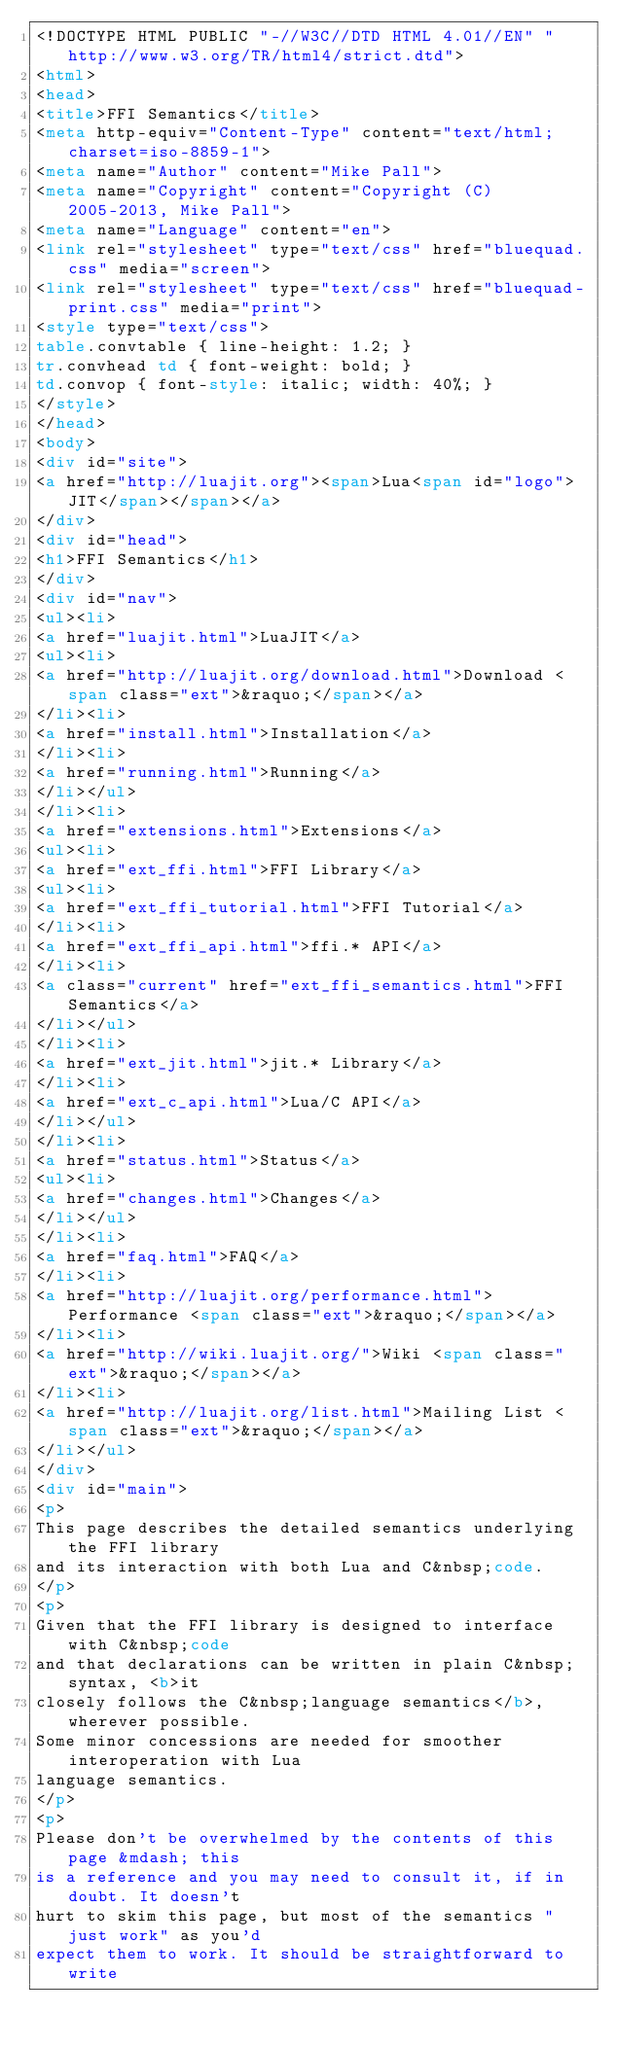Convert code to text. <code><loc_0><loc_0><loc_500><loc_500><_HTML_><!DOCTYPE HTML PUBLIC "-//W3C//DTD HTML 4.01//EN" "http://www.w3.org/TR/html4/strict.dtd">
<html>
<head>
<title>FFI Semantics</title>
<meta http-equiv="Content-Type" content="text/html; charset=iso-8859-1">
<meta name="Author" content="Mike Pall">
<meta name="Copyright" content="Copyright (C) 2005-2013, Mike Pall">
<meta name="Language" content="en">
<link rel="stylesheet" type="text/css" href="bluequad.css" media="screen">
<link rel="stylesheet" type="text/css" href="bluequad-print.css" media="print">
<style type="text/css">
table.convtable { line-height: 1.2; }
tr.convhead td { font-weight: bold; }
td.convop { font-style: italic; width: 40%; }
</style>
</head>
<body>
<div id="site">
<a href="http://luajit.org"><span>Lua<span id="logo">JIT</span></span></a>
</div>
<div id="head">
<h1>FFI Semantics</h1>
</div>
<div id="nav">
<ul><li>
<a href="luajit.html">LuaJIT</a>
<ul><li>
<a href="http://luajit.org/download.html">Download <span class="ext">&raquo;</span></a>
</li><li>
<a href="install.html">Installation</a>
</li><li>
<a href="running.html">Running</a>
</li></ul>
</li><li>
<a href="extensions.html">Extensions</a>
<ul><li>
<a href="ext_ffi.html">FFI Library</a>
<ul><li>
<a href="ext_ffi_tutorial.html">FFI Tutorial</a>
</li><li>
<a href="ext_ffi_api.html">ffi.* API</a>
</li><li>
<a class="current" href="ext_ffi_semantics.html">FFI Semantics</a>
</li></ul>
</li><li>
<a href="ext_jit.html">jit.* Library</a>
</li><li>
<a href="ext_c_api.html">Lua/C API</a>
</li></ul>
</li><li>
<a href="status.html">Status</a>
<ul><li>
<a href="changes.html">Changes</a>
</li></ul>
</li><li>
<a href="faq.html">FAQ</a>
</li><li>
<a href="http://luajit.org/performance.html">Performance <span class="ext">&raquo;</span></a>
</li><li>
<a href="http://wiki.luajit.org/">Wiki <span class="ext">&raquo;</span></a>
</li><li>
<a href="http://luajit.org/list.html">Mailing List <span class="ext">&raquo;</span></a>
</li></ul>
</div>
<div id="main">
<p>
This page describes the detailed semantics underlying the FFI library
and its interaction with both Lua and C&nbsp;code.
</p>
<p>
Given that the FFI library is designed to interface with C&nbsp;code
and that declarations can be written in plain C&nbsp;syntax, <b>it
closely follows the C&nbsp;language semantics</b>, wherever possible.
Some minor concessions are needed for smoother interoperation with Lua
language semantics.
</p>
<p>
Please don't be overwhelmed by the contents of this page &mdash; this
is a reference and you may need to consult it, if in doubt. It doesn't
hurt to skim this page, but most of the semantics "just work" as you'd
expect them to work. It should be straightforward to write</code> 